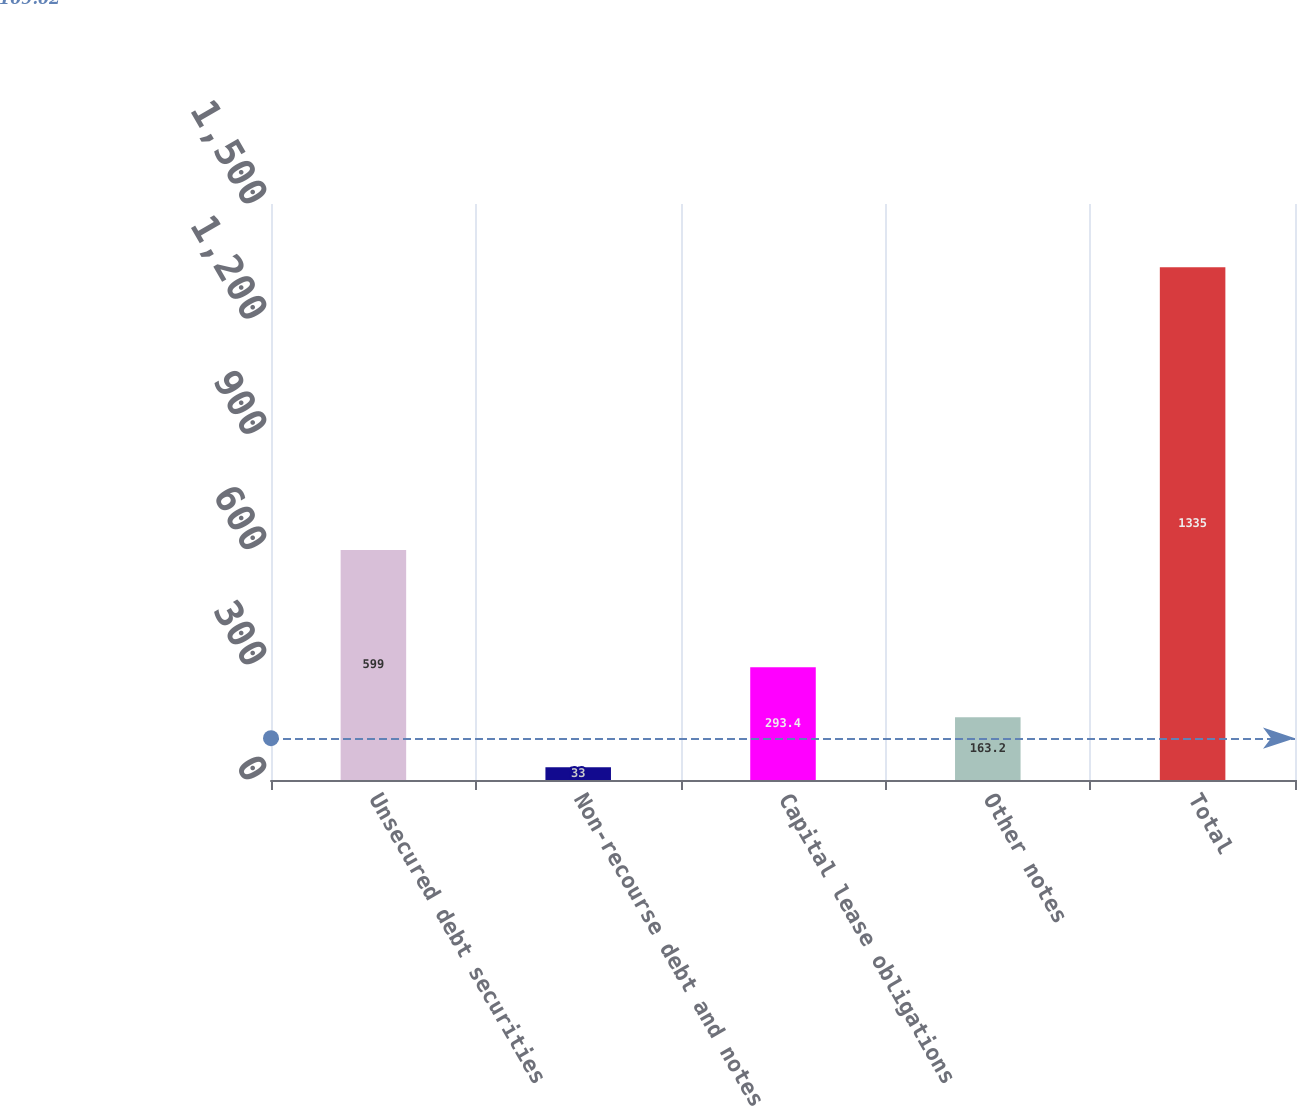Convert chart. <chart><loc_0><loc_0><loc_500><loc_500><bar_chart><fcel>Unsecured debt securities<fcel>Non-recourse debt and notes<fcel>Capital lease obligations<fcel>Other notes<fcel>Total<nl><fcel>599<fcel>33<fcel>293.4<fcel>163.2<fcel>1335<nl></chart> 